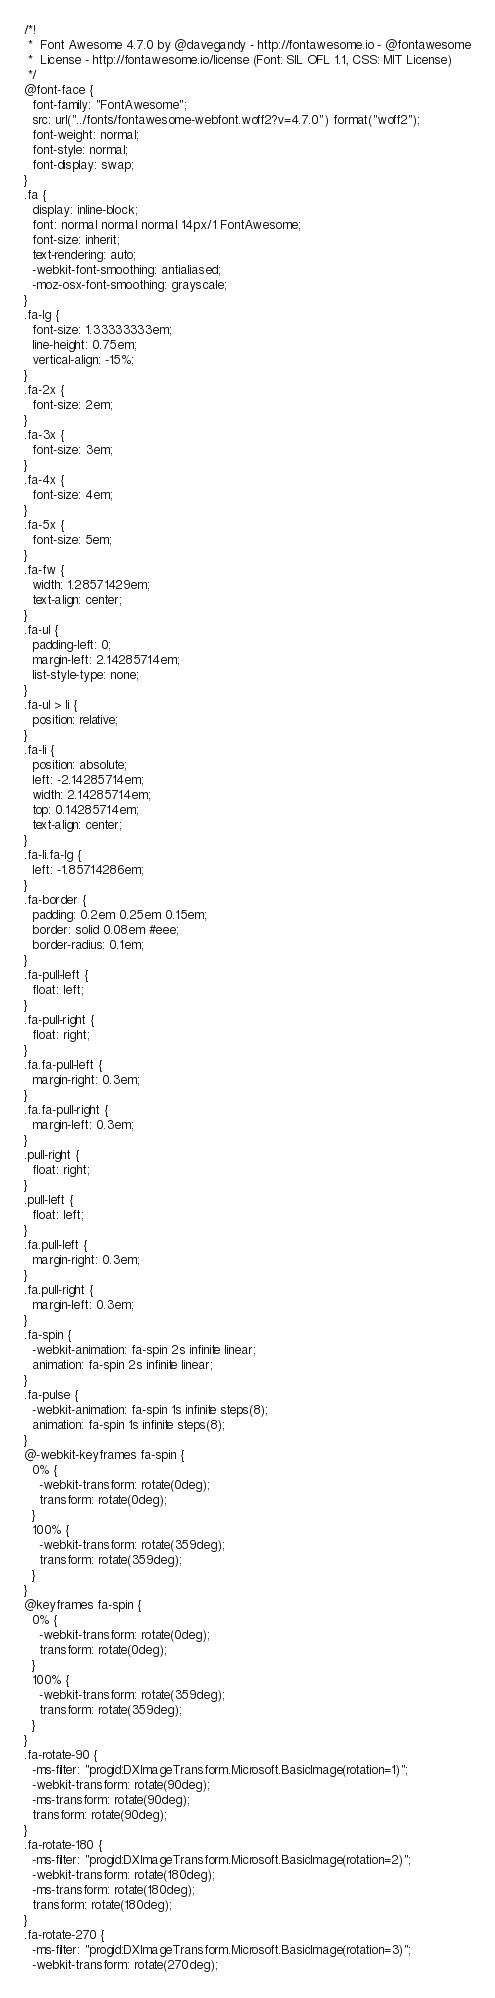<code> <loc_0><loc_0><loc_500><loc_500><_CSS_>/*!
 *  Font Awesome 4.7.0 by @davegandy - http://fontawesome.io - @fontawesome
 *  License - http://fontawesome.io/license (Font: SIL OFL 1.1, CSS: MIT License)
 */
@font-face {
  font-family: "FontAwesome";
  src: url("../fonts/fontawesome-webfont.woff2?v=4.7.0") format("woff2");
  font-weight: normal;
  font-style: normal;
  font-display: swap;
}
.fa {
  display: inline-block;
  font: normal normal normal 14px/1 FontAwesome;
  font-size: inherit;
  text-rendering: auto;
  -webkit-font-smoothing: antialiased;
  -moz-osx-font-smoothing: grayscale;
}
.fa-lg {
  font-size: 1.33333333em;
  line-height: 0.75em;
  vertical-align: -15%;
}
.fa-2x {
  font-size: 2em;
}
.fa-3x {
  font-size: 3em;
}
.fa-4x {
  font-size: 4em;
}
.fa-5x {
  font-size: 5em;
}
.fa-fw {
  width: 1.28571429em;
  text-align: center;
}
.fa-ul {
  padding-left: 0;
  margin-left: 2.14285714em;
  list-style-type: none;
}
.fa-ul > li {
  position: relative;
}
.fa-li {
  position: absolute;
  left: -2.14285714em;
  width: 2.14285714em;
  top: 0.14285714em;
  text-align: center;
}
.fa-li.fa-lg {
  left: -1.85714286em;
}
.fa-border {
  padding: 0.2em 0.25em 0.15em;
  border: solid 0.08em #eee;
  border-radius: 0.1em;
}
.fa-pull-left {
  float: left;
}
.fa-pull-right {
  float: right;
}
.fa.fa-pull-left {
  margin-right: 0.3em;
}
.fa.fa-pull-right {
  margin-left: 0.3em;
}
.pull-right {
  float: right;
}
.pull-left {
  float: left;
}
.fa.pull-left {
  margin-right: 0.3em;
}
.fa.pull-right {
  margin-left: 0.3em;
}
.fa-spin {
  -webkit-animation: fa-spin 2s infinite linear;
  animation: fa-spin 2s infinite linear;
}
.fa-pulse {
  -webkit-animation: fa-spin 1s infinite steps(8);
  animation: fa-spin 1s infinite steps(8);
}
@-webkit-keyframes fa-spin {
  0% {
    -webkit-transform: rotate(0deg);
    transform: rotate(0deg);
  }
  100% {
    -webkit-transform: rotate(359deg);
    transform: rotate(359deg);
  }
}
@keyframes fa-spin {
  0% {
    -webkit-transform: rotate(0deg);
    transform: rotate(0deg);
  }
  100% {
    -webkit-transform: rotate(359deg);
    transform: rotate(359deg);
  }
}
.fa-rotate-90 {
  -ms-filter: "progid:DXImageTransform.Microsoft.BasicImage(rotation=1)";
  -webkit-transform: rotate(90deg);
  -ms-transform: rotate(90deg);
  transform: rotate(90deg);
}
.fa-rotate-180 {
  -ms-filter: "progid:DXImageTransform.Microsoft.BasicImage(rotation=2)";
  -webkit-transform: rotate(180deg);
  -ms-transform: rotate(180deg);
  transform: rotate(180deg);
}
.fa-rotate-270 {
  -ms-filter: "progid:DXImageTransform.Microsoft.BasicImage(rotation=3)";
  -webkit-transform: rotate(270deg);</code> 